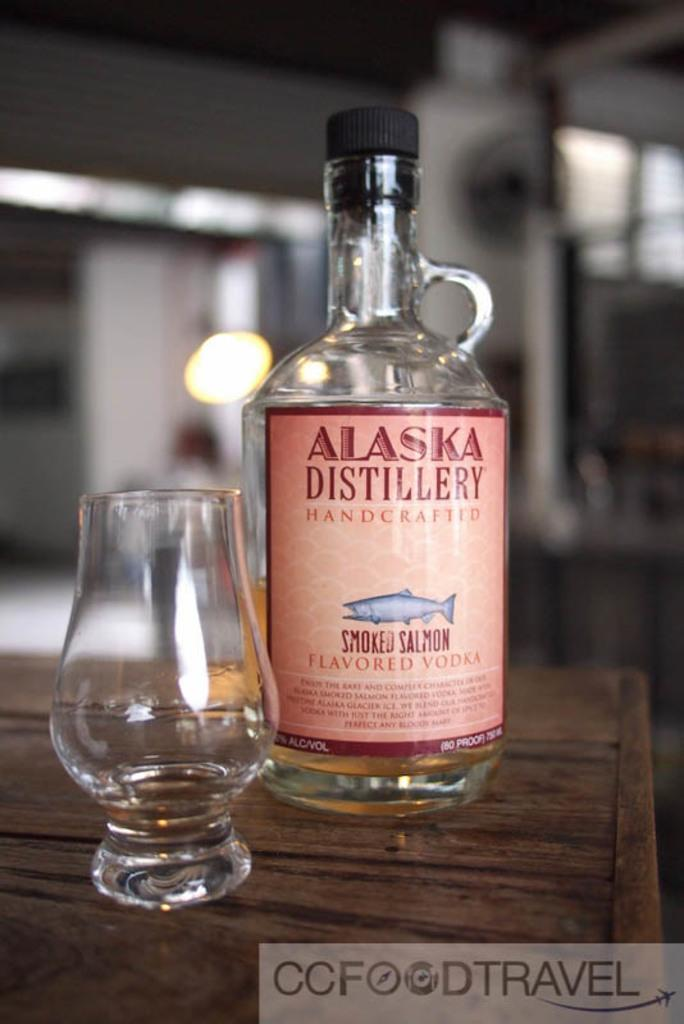<image>
Relay a brief, clear account of the picture shown. a glass and bottle of Alaska Distillery Smoked Salmon flavor vodka 